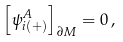Convert formula to latex. <formula><loc_0><loc_0><loc_500><loc_500>\left [ \psi _ { i ( + ) } ^ { A } \right ] _ { \partial M } = 0 \, ,</formula> 